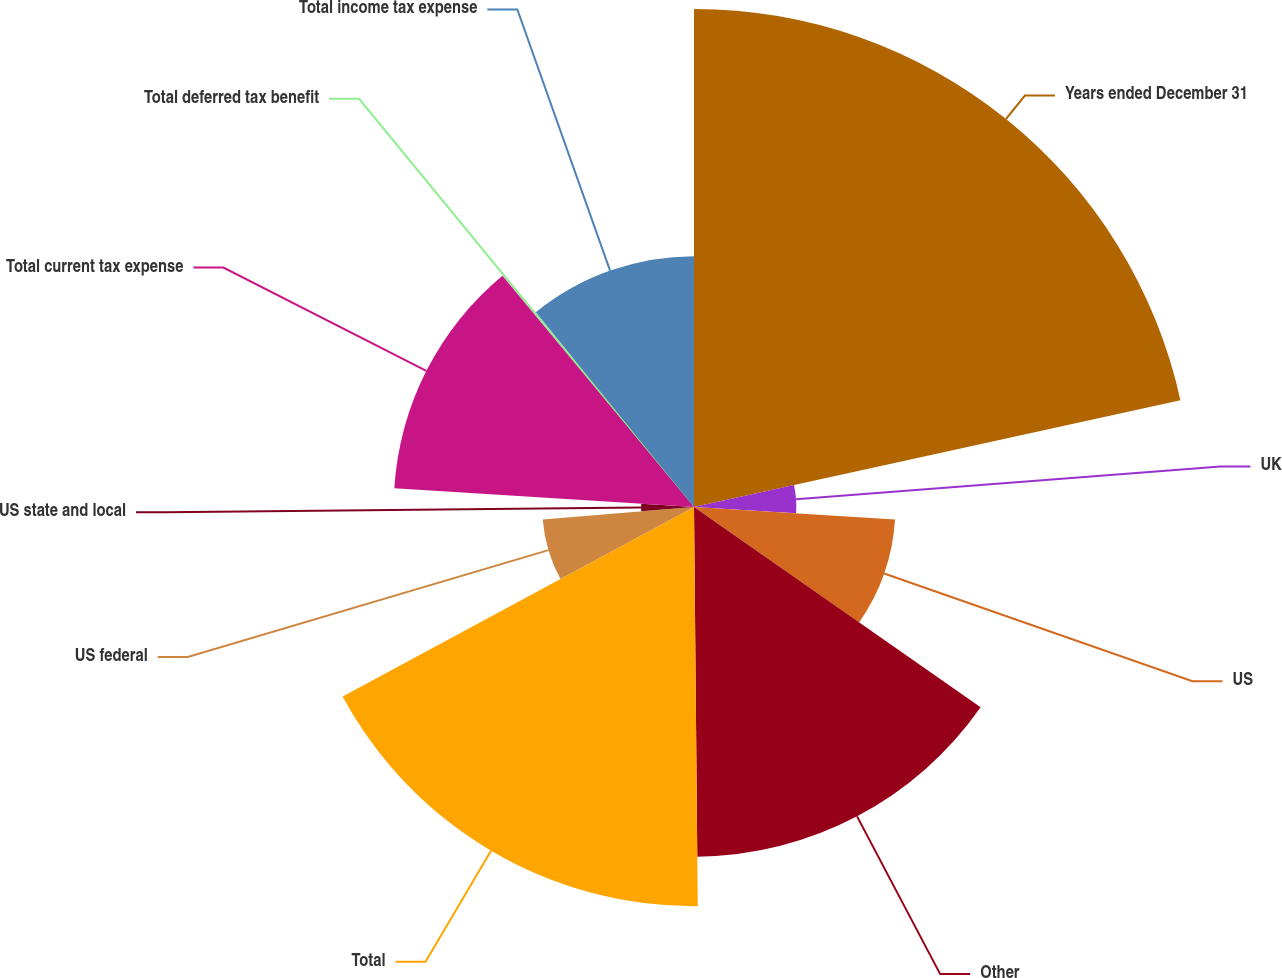<chart> <loc_0><loc_0><loc_500><loc_500><pie_chart><fcel>Years ended December 31<fcel>UK<fcel>US<fcel>Other<fcel>Total<fcel>US federal<fcel>US state and local<fcel>Total current tax expense<fcel>Total deferred tax benefit<fcel>Total income tax expense<nl><fcel>21.56%<fcel>4.43%<fcel>8.72%<fcel>15.14%<fcel>17.28%<fcel>6.57%<fcel>2.29%<fcel>13.0%<fcel>0.15%<fcel>10.86%<nl></chart> 